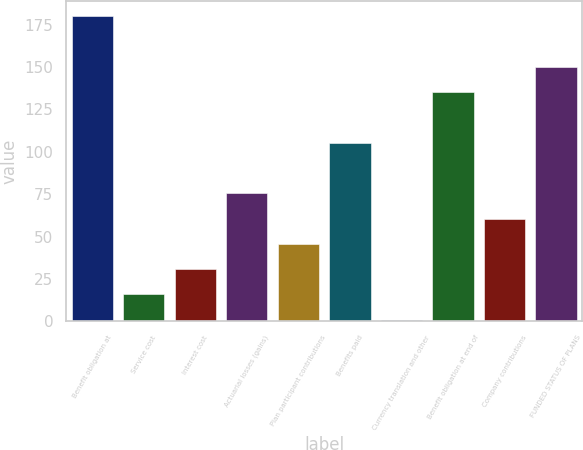<chart> <loc_0><loc_0><loc_500><loc_500><bar_chart><fcel>Benefit obligation at<fcel>Service cost<fcel>Interest cost<fcel>Actuarial losses (gains)<fcel>Plan participant contributions<fcel>Benefits paid<fcel>Currency translation and other<fcel>Benefit obligation at end of<fcel>Company contributions<fcel>FUNDED STATUS OF PLANS<nl><fcel>180.06<fcel>15.83<fcel>30.76<fcel>75.55<fcel>45.69<fcel>105.41<fcel>0.9<fcel>135.27<fcel>60.62<fcel>150.2<nl></chart> 